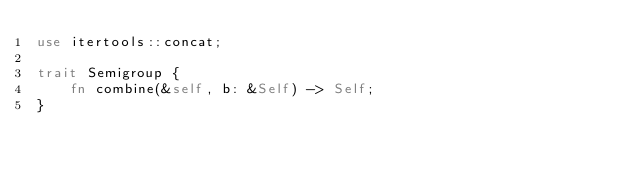Convert code to text. <code><loc_0><loc_0><loc_500><loc_500><_Rust_>use itertools::concat;

trait Semigroup {
    fn combine(&self, b: &Self) -> Self;
}
</code> 